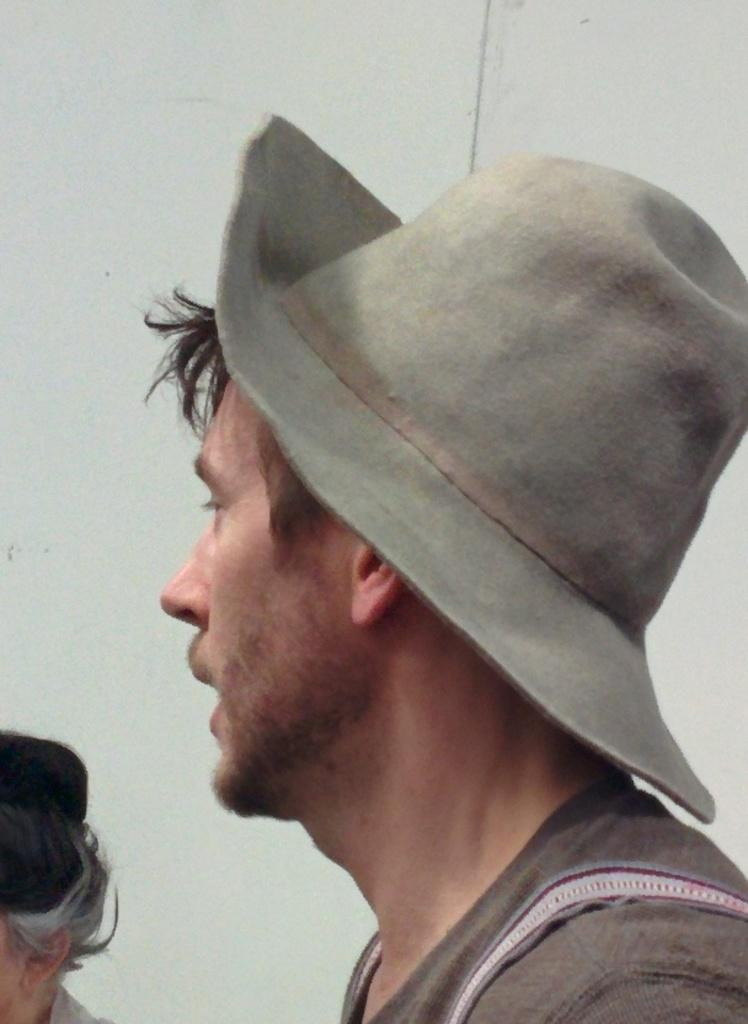What is the man in the image wearing on his upper body? The man is wearing a black T-shirt. What type of headwear is the man wearing in the image? The man is wearing a grey hat. What is the man doing in the image? The man appears to be talking. Who else is present in the image? There is a woman in the image. What can be seen in the background of the image? There is a white wall in the background of the image. What time does the clock in the image show? There is no clock present in the image. What suggestion does the writer in the image make to the man? There is no writer or suggestion present in the image. 